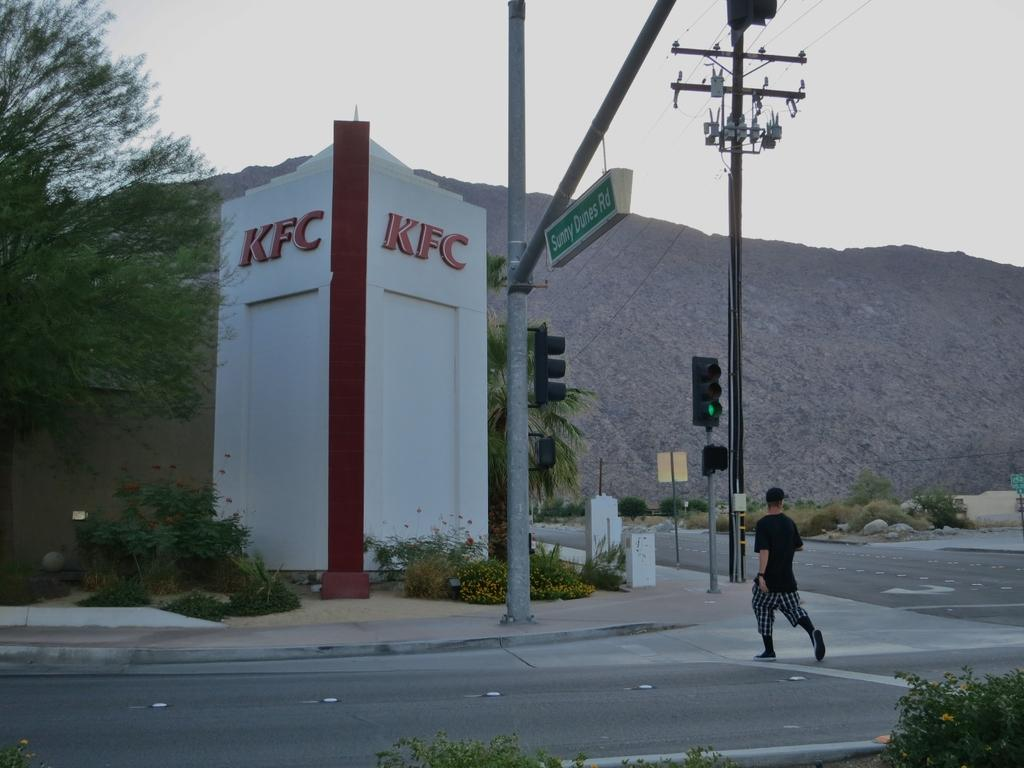What is the main feature of the image? There is a road in the image. Can you describe any other elements in the image? There is a person, a traffic signal pole, an electric pole with wires, and plants and trees visible near the side of the road. What is the manager doing in the image? There is no manager present in the image. Can you describe the beetle crawling on the traffic signal pole? There is no beetle present on the traffic signal pole in the image. 